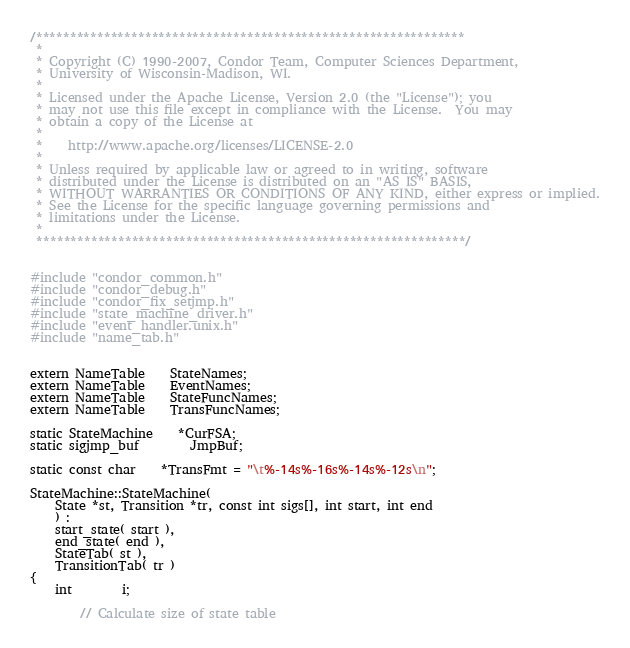Convert code to text. <code><loc_0><loc_0><loc_500><loc_500><_C++_>/***************************************************************
 *
 * Copyright (C) 1990-2007, Condor Team, Computer Sciences Department,
 * University of Wisconsin-Madison, WI.
 * 
 * Licensed under the Apache License, Version 2.0 (the "License"); you
 * may not use this file except in compliance with the License.  You may
 * obtain a copy of the License at
 * 
 *    http://www.apache.org/licenses/LICENSE-2.0
 * 
 * Unless required by applicable law or agreed to in writing, software
 * distributed under the License is distributed on an "AS IS" BASIS,
 * WITHOUT WARRANTIES OR CONDITIONS OF ANY KIND, either express or implied.
 * See the License for the specific language governing permissions and
 * limitations under the License.
 *
 ***************************************************************/


#include "condor_common.h"
#include "condor_debug.h"
#include "condor_fix_setjmp.h"
#include "state_machine_driver.h"
#include "event_handler.unix.h"
#include "name_tab.h"


extern NameTable	StateNames;
extern NameTable	EventNames;
extern NameTable 	StateFuncNames;
extern NameTable	TransFuncNames;

static StateMachine	*CurFSA;
static sigjmp_buf		JmpBuf;

static const char	*TransFmt = "\t%-14s%-16s%-14s%-12s\n";

StateMachine::StateMachine(
	State *st, Transition *tr, const int sigs[], int start, int end
	) :
	start_state( start ),
	end_state( end ),
	StateTab( st ),
	TransitionTab( tr )
{
	int		i;

		// Calculate size of state table</code> 